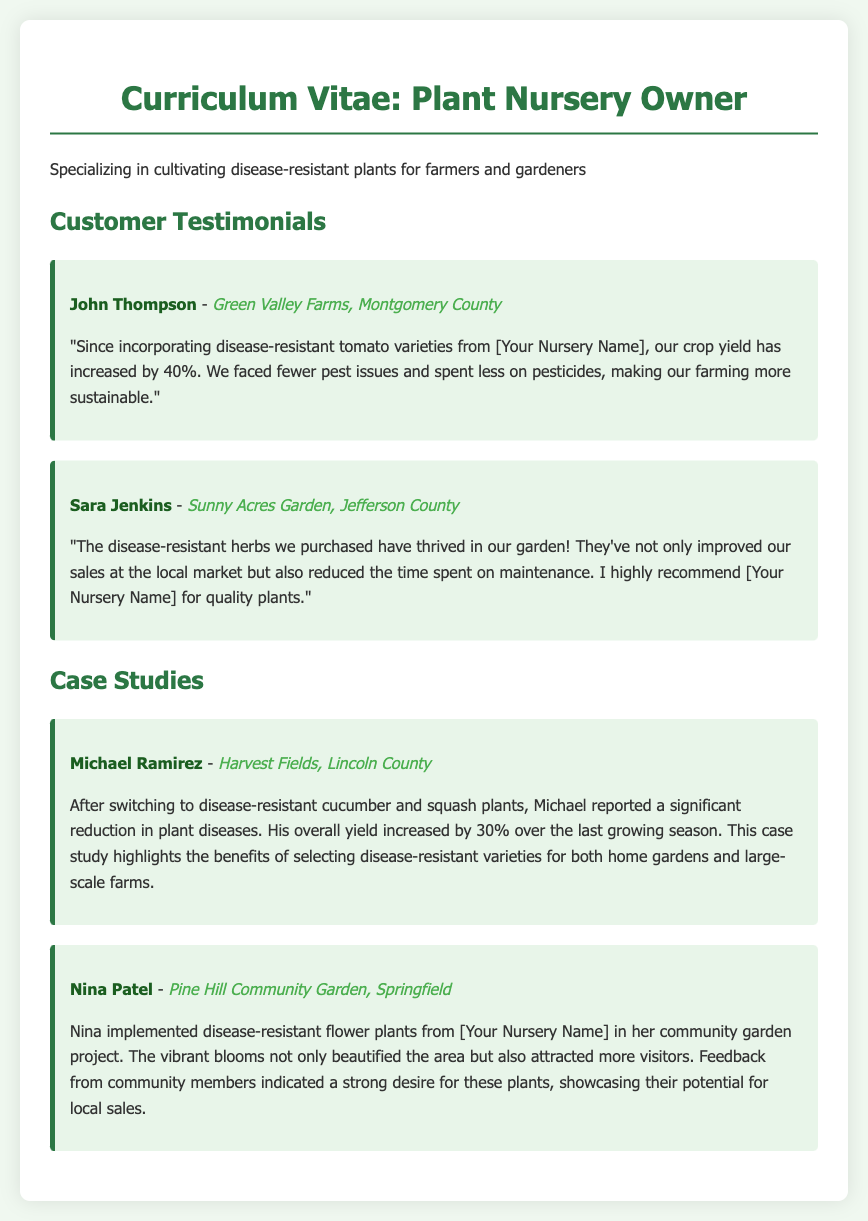What is John Thompson's location? John Thompson is located at Green Valley Farms in Montgomery County.
Answer: Green Valley Farms, Montgomery County What percentage did crop yield increase for John Thompson? John Thompson reported a 40% increase in crop yield after incorporating disease-resistant tomato varieties.
Answer: 40% Which disease-resistant plants did Michael Ramirez switch to? Michael Ramirez switched to disease-resistant cucumber and squash plants as highlighted in the case study.
Answer: Cucumber and squash What was the overall yield increase reported by Michael Ramirez? Michael Ramirez reported a 30% increase in overall yield after making the switch.
Answer: 30% What positive impact did disease-resistant herbs have for Sara Jenkins? Sara Jenkins noted that the disease-resistant herbs improved sales at the local market and reduced maintenance time.
Answer: Improved sales, reduced maintenance Which community garden project did Nina Patel contribute to? Nina Patel implemented disease-resistant flower plants in the Pine Hill Community Garden project as mentioned in the case study.
Answer: Pine Hill Community Garden What feedback did Nina Patel receive from community members? Community members expressed a strong desire for the disease-resistant flower plants used by Nina Patel.
Answer: Strong desire for these plants Who is the owner of the nursery mentioned in testimonials? The nursery in the testimonials is referred to as [Your Nursery Name], indicating ownership by the testimonial provider.
Answer: [Your Nursery Name] 